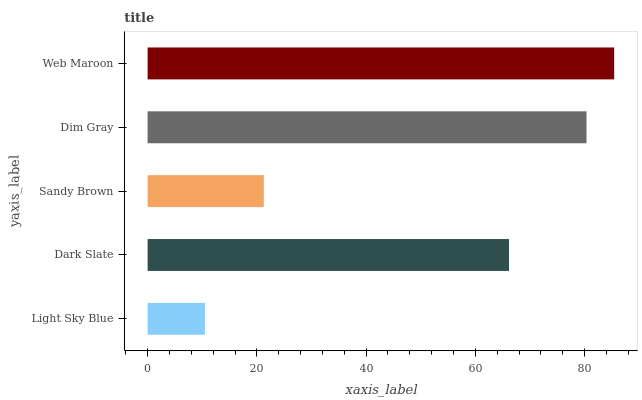Is Light Sky Blue the minimum?
Answer yes or no. Yes. Is Web Maroon the maximum?
Answer yes or no. Yes. Is Dark Slate the minimum?
Answer yes or no. No. Is Dark Slate the maximum?
Answer yes or no. No. Is Dark Slate greater than Light Sky Blue?
Answer yes or no. Yes. Is Light Sky Blue less than Dark Slate?
Answer yes or no. Yes. Is Light Sky Blue greater than Dark Slate?
Answer yes or no. No. Is Dark Slate less than Light Sky Blue?
Answer yes or no. No. Is Dark Slate the high median?
Answer yes or no. Yes. Is Dark Slate the low median?
Answer yes or no. Yes. Is Dim Gray the high median?
Answer yes or no. No. Is Light Sky Blue the low median?
Answer yes or no. No. 